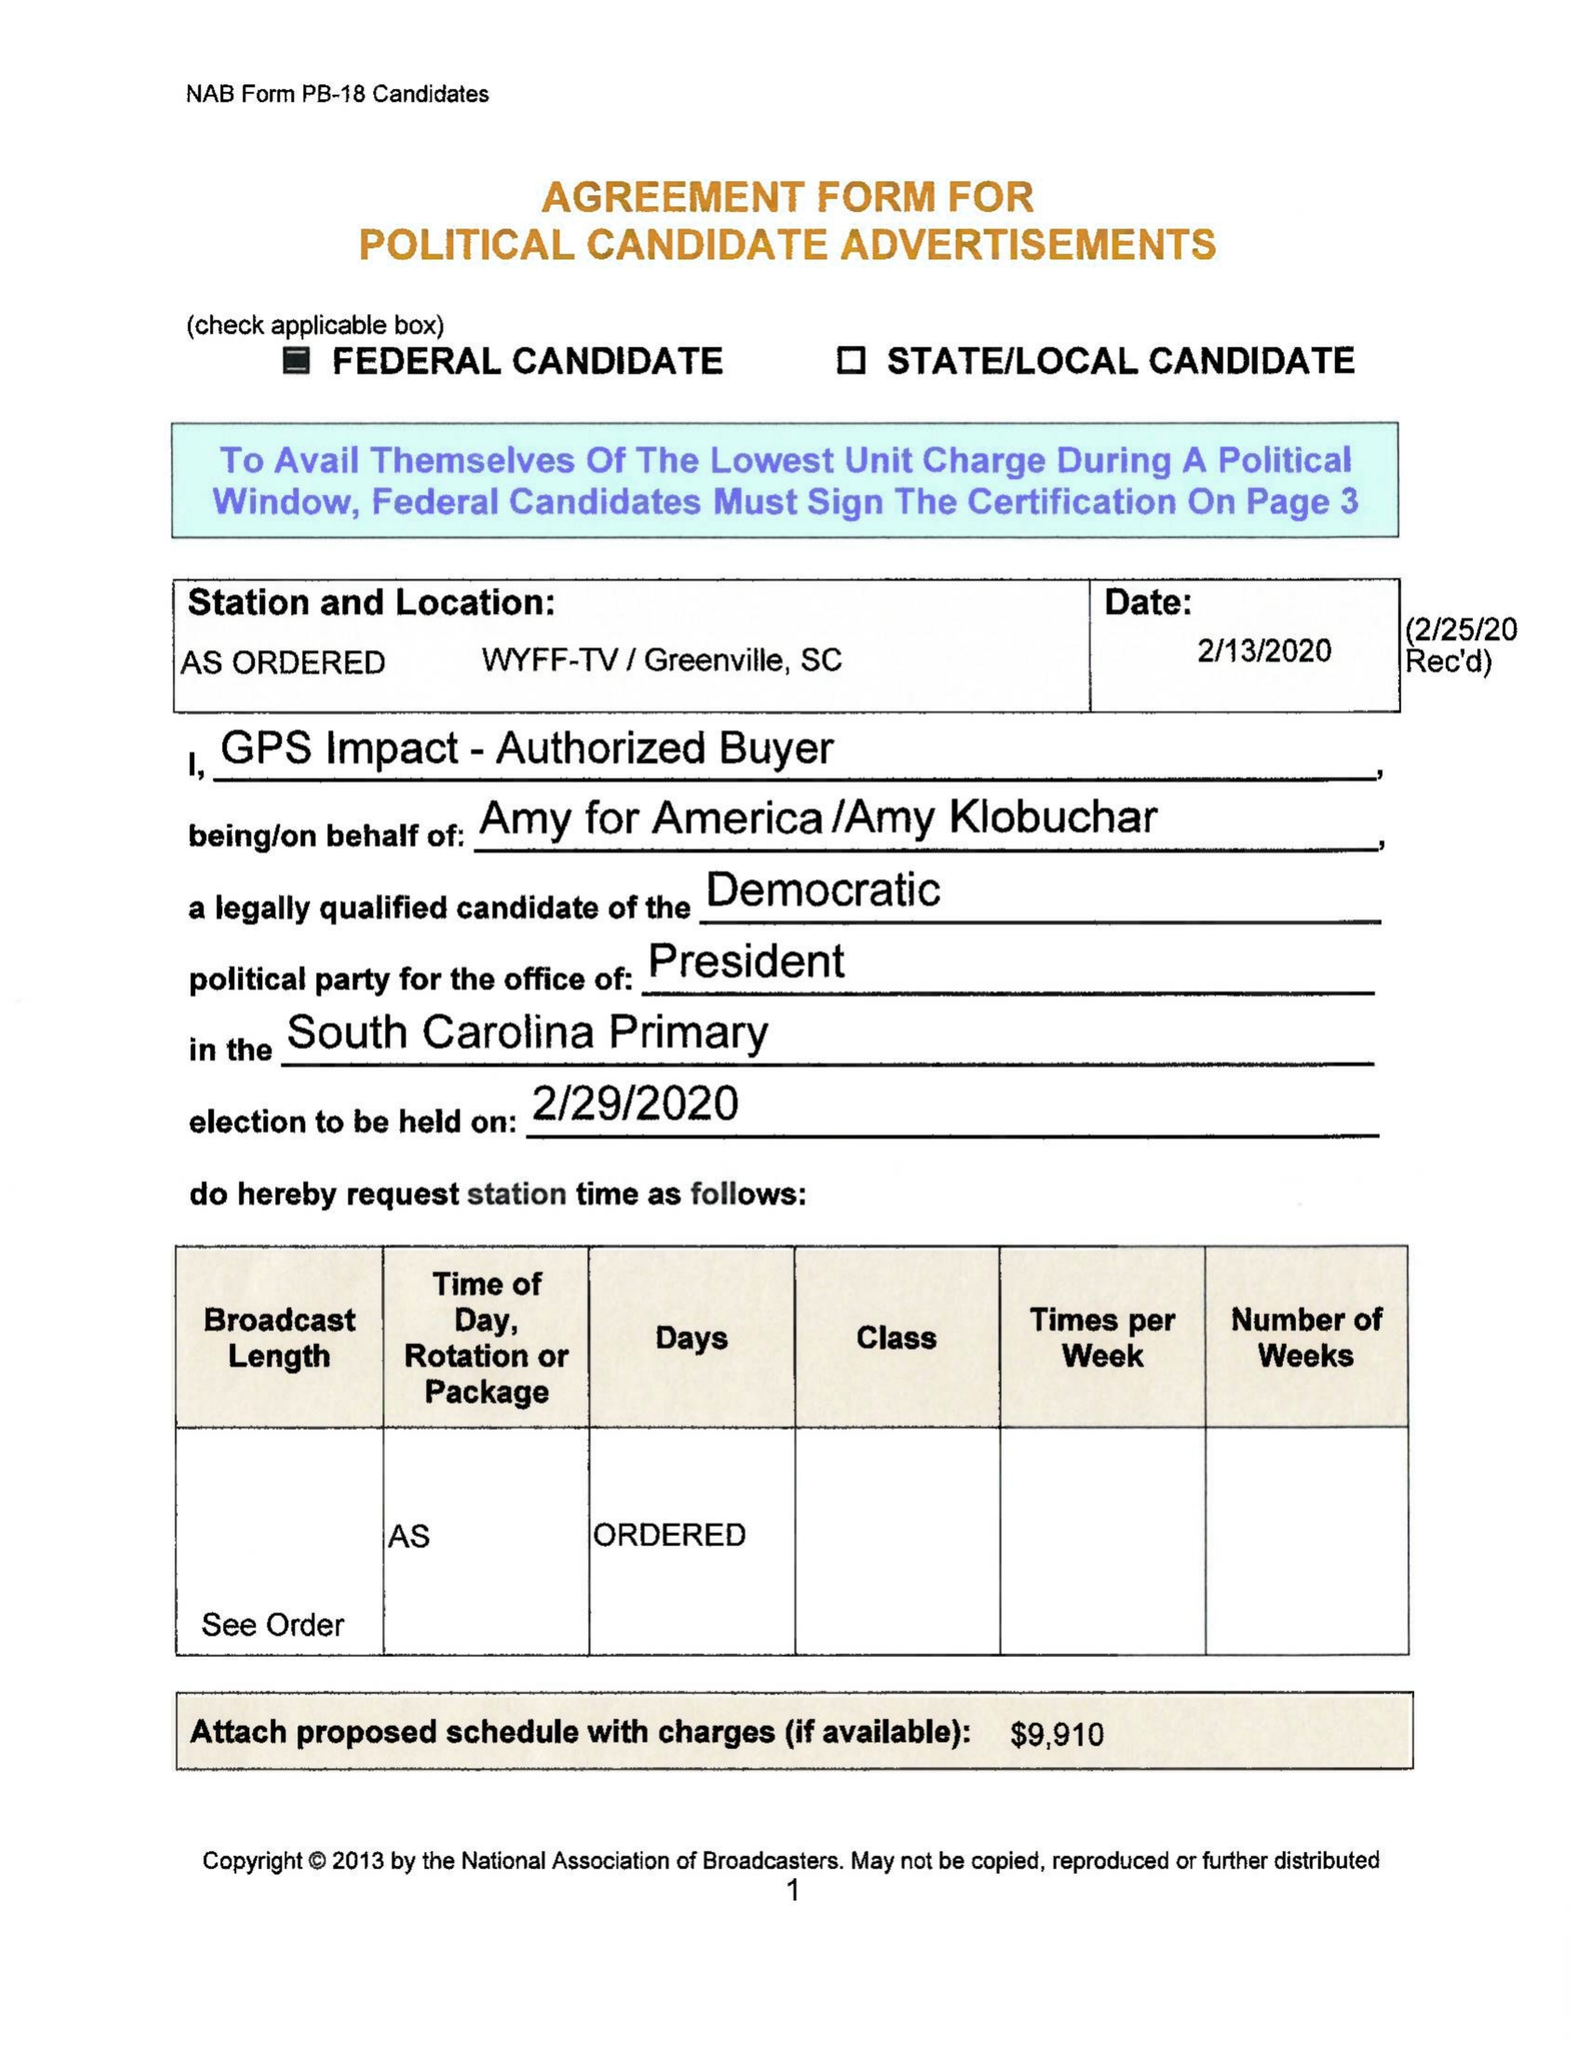What is the value for the flight_to?
Answer the question using a single word or phrase. None 